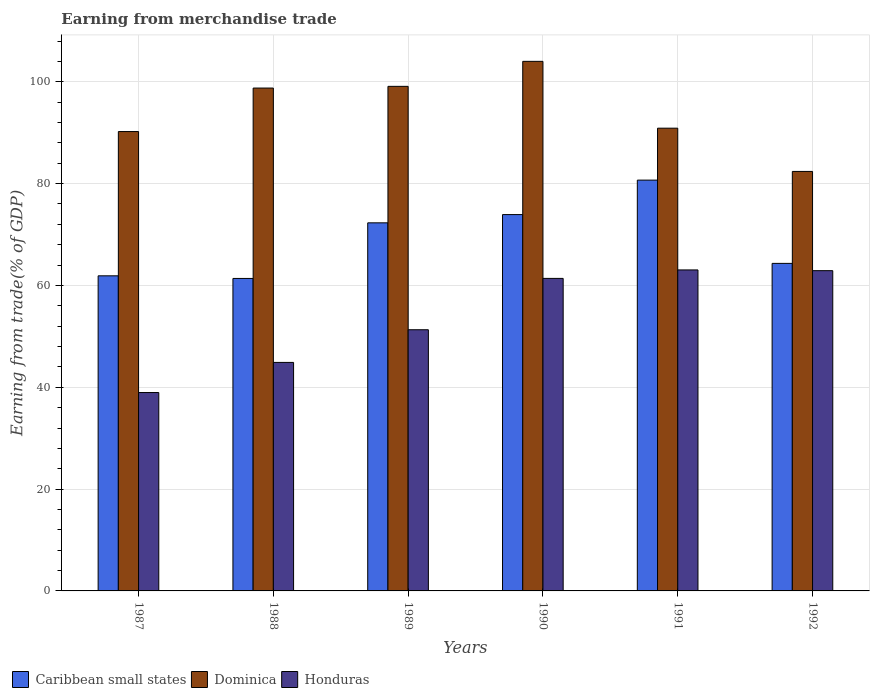How many groups of bars are there?
Offer a terse response. 6. Are the number of bars per tick equal to the number of legend labels?
Ensure brevity in your answer.  Yes. Are the number of bars on each tick of the X-axis equal?
Provide a succinct answer. Yes. How many bars are there on the 5th tick from the right?
Give a very brief answer. 3. What is the label of the 6th group of bars from the left?
Provide a succinct answer. 1992. In how many cases, is the number of bars for a given year not equal to the number of legend labels?
Ensure brevity in your answer.  0. What is the earnings from trade in Caribbean small states in 1990?
Keep it short and to the point. 73.92. Across all years, what is the maximum earnings from trade in Dominica?
Give a very brief answer. 104.01. Across all years, what is the minimum earnings from trade in Dominica?
Keep it short and to the point. 82.39. In which year was the earnings from trade in Honduras maximum?
Give a very brief answer. 1991. What is the total earnings from trade in Honduras in the graph?
Offer a terse response. 322.48. What is the difference between the earnings from trade in Caribbean small states in 1988 and that in 1991?
Provide a succinct answer. -19.31. What is the difference between the earnings from trade in Honduras in 1988 and the earnings from trade in Dominica in 1991?
Your answer should be very brief. -46.01. What is the average earnings from trade in Dominica per year?
Your response must be concise. 94.23. In the year 1988, what is the difference between the earnings from trade in Honduras and earnings from trade in Caribbean small states?
Keep it short and to the point. -16.49. What is the ratio of the earnings from trade in Caribbean small states in 1989 to that in 1990?
Your answer should be compact. 0.98. What is the difference between the highest and the second highest earnings from trade in Caribbean small states?
Your answer should be very brief. 6.77. What is the difference between the highest and the lowest earnings from trade in Caribbean small states?
Provide a short and direct response. 19.31. In how many years, is the earnings from trade in Caribbean small states greater than the average earnings from trade in Caribbean small states taken over all years?
Ensure brevity in your answer.  3. Is the sum of the earnings from trade in Dominica in 1989 and 1991 greater than the maximum earnings from trade in Honduras across all years?
Provide a succinct answer. Yes. What does the 2nd bar from the left in 1988 represents?
Your answer should be very brief. Dominica. What does the 2nd bar from the right in 1988 represents?
Your answer should be very brief. Dominica. Is it the case that in every year, the sum of the earnings from trade in Caribbean small states and earnings from trade in Dominica is greater than the earnings from trade in Honduras?
Ensure brevity in your answer.  Yes. How many bars are there?
Your response must be concise. 18. How many years are there in the graph?
Offer a very short reply. 6. Are the values on the major ticks of Y-axis written in scientific E-notation?
Make the answer very short. No. Does the graph contain grids?
Your answer should be compact. Yes. Where does the legend appear in the graph?
Ensure brevity in your answer.  Bottom left. How many legend labels are there?
Give a very brief answer. 3. How are the legend labels stacked?
Your answer should be very brief. Horizontal. What is the title of the graph?
Your answer should be very brief. Earning from merchandise trade. What is the label or title of the Y-axis?
Offer a very short reply. Earning from trade(% of GDP). What is the Earning from trade(% of GDP) in Caribbean small states in 1987?
Provide a short and direct response. 61.89. What is the Earning from trade(% of GDP) in Dominica in 1987?
Provide a short and direct response. 90.23. What is the Earning from trade(% of GDP) of Honduras in 1987?
Ensure brevity in your answer.  38.96. What is the Earning from trade(% of GDP) of Caribbean small states in 1988?
Give a very brief answer. 61.38. What is the Earning from trade(% of GDP) in Dominica in 1988?
Your answer should be compact. 98.77. What is the Earning from trade(% of GDP) of Honduras in 1988?
Keep it short and to the point. 44.88. What is the Earning from trade(% of GDP) of Caribbean small states in 1989?
Provide a short and direct response. 72.3. What is the Earning from trade(% of GDP) of Dominica in 1989?
Offer a terse response. 99.1. What is the Earning from trade(% of GDP) of Honduras in 1989?
Give a very brief answer. 51.3. What is the Earning from trade(% of GDP) in Caribbean small states in 1990?
Provide a succinct answer. 73.92. What is the Earning from trade(% of GDP) of Dominica in 1990?
Your answer should be compact. 104.01. What is the Earning from trade(% of GDP) of Honduras in 1990?
Offer a very short reply. 61.38. What is the Earning from trade(% of GDP) in Caribbean small states in 1991?
Keep it short and to the point. 80.69. What is the Earning from trade(% of GDP) in Dominica in 1991?
Provide a succinct answer. 90.89. What is the Earning from trade(% of GDP) of Honduras in 1991?
Offer a terse response. 63.05. What is the Earning from trade(% of GDP) of Caribbean small states in 1992?
Provide a short and direct response. 64.33. What is the Earning from trade(% of GDP) of Dominica in 1992?
Offer a very short reply. 82.39. What is the Earning from trade(% of GDP) of Honduras in 1992?
Your answer should be compact. 62.9. Across all years, what is the maximum Earning from trade(% of GDP) in Caribbean small states?
Offer a very short reply. 80.69. Across all years, what is the maximum Earning from trade(% of GDP) in Dominica?
Make the answer very short. 104.01. Across all years, what is the maximum Earning from trade(% of GDP) of Honduras?
Offer a very short reply. 63.05. Across all years, what is the minimum Earning from trade(% of GDP) of Caribbean small states?
Give a very brief answer. 61.38. Across all years, what is the minimum Earning from trade(% of GDP) in Dominica?
Ensure brevity in your answer.  82.39. Across all years, what is the minimum Earning from trade(% of GDP) in Honduras?
Provide a short and direct response. 38.96. What is the total Earning from trade(% of GDP) of Caribbean small states in the graph?
Keep it short and to the point. 414.5. What is the total Earning from trade(% of GDP) in Dominica in the graph?
Offer a terse response. 565.4. What is the total Earning from trade(% of GDP) of Honduras in the graph?
Make the answer very short. 322.48. What is the difference between the Earning from trade(% of GDP) in Caribbean small states in 1987 and that in 1988?
Ensure brevity in your answer.  0.51. What is the difference between the Earning from trade(% of GDP) in Dominica in 1987 and that in 1988?
Offer a terse response. -8.54. What is the difference between the Earning from trade(% of GDP) in Honduras in 1987 and that in 1988?
Offer a terse response. -5.92. What is the difference between the Earning from trade(% of GDP) of Caribbean small states in 1987 and that in 1989?
Keep it short and to the point. -10.41. What is the difference between the Earning from trade(% of GDP) of Dominica in 1987 and that in 1989?
Provide a succinct answer. -8.88. What is the difference between the Earning from trade(% of GDP) of Honduras in 1987 and that in 1989?
Make the answer very short. -12.33. What is the difference between the Earning from trade(% of GDP) of Caribbean small states in 1987 and that in 1990?
Offer a very short reply. -12.03. What is the difference between the Earning from trade(% of GDP) in Dominica in 1987 and that in 1990?
Make the answer very short. -13.79. What is the difference between the Earning from trade(% of GDP) in Honduras in 1987 and that in 1990?
Your response must be concise. -22.42. What is the difference between the Earning from trade(% of GDP) in Caribbean small states in 1987 and that in 1991?
Offer a terse response. -18.8. What is the difference between the Earning from trade(% of GDP) in Dominica in 1987 and that in 1991?
Keep it short and to the point. -0.66. What is the difference between the Earning from trade(% of GDP) of Honduras in 1987 and that in 1991?
Give a very brief answer. -24.08. What is the difference between the Earning from trade(% of GDP) in Caribbean small states in 1987 and that in 1992?
Offer a terse response. -2.44. What is the difference between the Earning from trade(% of GDP) in Dominica in 1987 and that in 1992?
Keep it short and to the point. 7.83. What is the difference between the Earning from trade(% of GDP) of Honduras in 1987 and that in 1992?
Your answer should be compact. -23.94. What is the difference between the Earning from trade(% of GDP) in Caribbean small states in 1988 and that in 1989?
Offer a very short reply. -10.92. What is the difference between the Earning from trade(% of GDP) in Dominica in 1988 and that in 1989?
Your answer should be compact. -0.33. What is the difference between the Earning from trade(% of GDP) in Honduras in 1988 and that in 1989?
Your answer should be very brief. -6.42. What is the difference between the Earning from trade(% of GDP) of Caribbean small states in 1988 and that in 1990?
Your response must be concise. -12.54. What is the difference between the Earning from trade(% of GDP) in Dominica in 1988 and that in 1990?
Your response must be concise. -5.24. What is the difference between the Earning from trade(% of GDP) in Honduras in 1988 and that in 1990?
Ensure brevity in your answer.  -16.5. What is the difference between the Earning from trade(% of GDP) of Caribbean small states in 1988 and that in 1991?
Offer a terse response. -19.31. What is the difference between the Earning from trade(% of GDP) in Dominica in 1988 and that in 1991?
Provide a succinct answer. 7.88. What is the difference between the Earning from trade(% of GDP) of Honduras in 1988 and that in 1991?
Ensure brevity in your answer.  -18.17. What is the difference between the Earning from trade(% of GDP) of Caribbean small states in 1988 and that in 1992?
Offer a terse response. -2.96. What is the difference between the Earning from trade(% of GDP) of Dominica in 1988 and that in 1992?
Offer a very short reply. 16.38. What is the difference between the Earning from trade(% of GDP) of Honduras in 1988 and that in 1992?
Provide a short and direct response. -18.02. What is the difference between the Earning from trade(% of GDP) in Caribbean small states in 1989 and that in 1990?
Provide a short and direct response. -1.62. What is the difference between the Earning from trade(% of GDP) in Dominica in 1989 and that in 1990?
Your response must be concise. -4.91. What is the difference between the Earning from trade(% of GDP) of Honduras in 1989 and that in 1990?
Your response must be concise. -10.08. What is the difference between the Earning from trade(% of GDP) of Caribbean small states in 1989 and that in 1991?
Keep it short and to the point. -8.39. What is the difference between the Earning from trade(% of GDP) in Dominica in 1989 and that in 1991?
Provide a succinct answer. 8.21. What is the difference between the Earning from trade(% of GDP) in Honduras in 1989 and that in 1991?
Offer a very short reply. -11.75. What is the difference between the Earning from trade(% of GDP) in Caribbean small states in 1989 and that in 1992?
Your answer should be very brief. 7.97. What is the difference between the Earning from trade(% of GDP) in Dominica in 1989 and that in 1992?
Provide a short and direct response. 16.71. What is the difference between the Earning from trade(% of GDP) of Honduras in 1989 and that in 1992?
Make the answer very short. -11.6. What is the difference between the Earning from trade(% of GDP) of Caribbean small states in 1990 and that in 1991?
Your answer should be compact. -6.77. What is the difference between the Earning from trade(% of GDP) in Dominica in 1990 and that in 1991?
Provide a succinct answer. 13.12. What is the difference between the Earning from trade(% of GDP) of Honduras in 1990 and that in 1991?
Provide a succinct answer. -1.67. What is the difference between the Earning from trade(% of GDP) in Caribbean small states in 1990 and that in 1992?
Ensure brevity in your answer.  9.59. What is the difference between the Earning from trade(% of GDP) of Dominica in 1990 and that in 1992?
Make the answer very short. 21.62. What is the difference between the Earning from trade(% of GDP) of Honduras in 1990 and that in 1992?
Ensure brevity in your answer.  -1.52. What is the difference between the Earning from trade(% of GDP) in Caribbean small states in 1991 and that in 1992?
Keep it short and to the point. 16.35. What is the difference between the Earning from trade(% of GDP) of Dominica in 1991 and that in 1992?
Offer a very short reply. 8.5. What is the difference between the Earning from trade(% of GDP) in Honduras in 1991 and that in 1992?
Give a very brief answer. 0.15. What is the difference between the Earning from trade(% of GDP) in Caribbean small states in 1987 and the Earning from trade(% of GDP) in Dominica in 1988?
Offer a very short reply. -36.88. What is the difference between the Earning from trade(% of GDP) of Caribbean small states in 1987 and the Earning from trade(% of GDP) of Honduras in 1988?
Keep it short and to the point. 17.01. What is the difference between the Earning from trade(% of GDP) in Dominica in 1987 and the Earning from trade(% of GDP) in Honduras in 1988?
Give a very brief answer. 45.34. What is the difference between the Earning from trade(% of GDP) of Caribbean small states in 1987 and the Earning from trade(% of GDP) of Dominica in 1989?
Offer a very short reply. -37.21. What is the difference between the Earning from trade(% of GDP) of Caribbean small states in 1987 and the Earning from trade(% of GDP) of Honduras in 1989?
Keep it short and to the point. 10.59. What is the difference between the Earning from trade(% of GDP) of Dominica in 1987 and the Earning from trade(% of GDP) of Honduras in 1989?
Offer a very short reply. 38.93. What is the difference between the Earning from trade(% of GDP) in Caribbean small states in 1987 and the Earning from trade(% of GDP) in Dominica in 1990?
Give a very brief answer. -42.12. What is the difference between the Earning from trade(% of GDP) in Caribbean small states in 1987 and the Earning from trade(% of GDP) in Honduras in 1990?
Keep it short and to the point. 0.51. What is the difference between the Earning from trade(% of GDP) in Dominica in 1987 and the Earning from trade(% of GDP) in Honduras in 1990?
Provide a short and direct response. 28.84. What is the difference between the Earning from trade(% of GDP) of Caribbean small states in 1987 and the Earning from trade(% of GDP) of Dominica in 1991?
Give a very brief answer. -29. What is the difference between the Earning from trade(% of GDP) in Caribbean small states in 1987 and the Earning from trade(% of GDP) in Honduras in 1991?
Keep it short and to the point. -1.16. What is the difference between the Earning from trade(% of GDP) in Dominica in 1987 and the Earning from trade(% of GDP) in Honduras in 1991?
Your answer should be compact. 27.18. What is the difference between the Earning from trade(% of GDP) in Caribbean small states in 1987 and the Earning from trade(% of GDP) in Dominica in 1992?
Offer a very short reply. -20.5. What is the difference between the Earning from trade(% of GDP) in Caribbean small states in 1987 and the Earning from trade(% of GDP) in Honduras in 1992?
Offer a terse response. -1.01. What is the difference between the Earning from trade(% of GDP) of Dominica in 1987 and the Earning from trade(% of GDP) of Honduras in 1992?
Provide a short and direct response. 27.32. What is the difference between the Earning from trade(% of GDP) of Caribbean small states in 1988 and the Earning from trade(% of GDP) of Dominica in 1989?
Ensure brevity in your answer.  -37.73. What is the difference between the Earning from trade(% of GDP) in Caribbean small states in 1988 and the Earning from trade(% of GDP) in Honduras in 1989?
Ensure brevity in your answer.  10.08. What is the difference between the Earning from trade(% of GDP) of Dominica in 1988 and the Earning from trade(% of GDP) of Honduras in 1989?
Keep it short and to the point. 47.47. What is the difference between the Earning from trade(% of GDP) of Caribbean small states in 1988 and the Earning from trade(% of GDP) of Dominica in 1990?
Ensure brevity in your answer.  -42.64. What is the difference between the Earning from trade(% of GDP) in Caribbean small states in 1988 and the Earning from trade(% of GDP) in Honduras in 1990?
Your answer should be compact. -0.01. What is the difference between the Earning from trade(% of GDP) in Dominica in 1988 and the Earning from trade(% of GDP) in Honduras in 1990?
Keep it short and to the point. 37.39. What is the difference between the Earning from trade(% of GDP) in Caribbean small states in 1988 and the Earning from trade(% of GDP) in Dominica in 1991?
Your answer should be compact. -29.51. What is the difference between the Earning from trade(% of GDP) of Caribbean small states in 1988 and the Earning from trade(% of GDP) of Honduras in 1991?
Ensure brevity in your answer.  -1.67. What is the difference between the Earning from trade(% of GDP) in Dominica in 1988 and the Earning from trade(% of GDP) in Honduras in 1991?
Your response must be concise. 35.72. What is the difference between the Earning from trade(% of GDP) of Caribbean small states in 1988 and the Earning from trade(% of GDP) of Dominica in 1992?
Give a very brief answer. -21.02. What is the difference between the Earning from trade(% of GDP) of Caribbean small states in 1988 and the Earning from trade(% of GDP) of Honduras in 1992?
Your answer should be compact. -1.53. What is the difference between the Earning from trade(% of GDP) of Dominica in 1988 and the Earning from trade(% of GDP) of Honduras in 1992?
Provide a short and direct response. 35.87. What is the difference between the Earning from trade(% of GDP) of Caribbean small states in 1989 and the Earning from trade(% of GDP) of Dominica in 1990?
Keep it short and to the point. -31.72. What is the difference between the Earning from trade(% of GDP) in Caribbean small states in 1989 and the Earning from trade(% of GDP) in Honduras in 1990?
Make the answer very short. 10.92. What is the difference between the Earning from trade(% of GDP) of Dominica in 1989 and the Earning from trade(% of GDP) of Honduras in 1990?
Your answer should be very brief. 37.72. What is the difference between the Earning from trade(% of GDP) in Caribbean small states in 1989 and the Earning from trade(% of GDP) in Dominica in 1991?
Give a very brief answer. -18.59. What is the difference between the Earning from trade(% of GDP) of Caribbean small states in 1989 and the Earning from trade(% of GDP) of Honduras in 1991?
Your response must be concise. 9.25. What is the difference between the Earning from trade(% of GDP) in Dominica in 1989 and the Earning from trade(% of GDP) in Honduras in 1991?
Give a very brief answer. 36.06. What is the difference between the Earning from trade(% of GDP) in Caribbean small states in 1989 and the Earning from trade(% of GDP) in Dominica in 1992?
Your answer should be compact. -10.1. What is the difference between the Earning from trade(% of GDP) in Caribbean small states in 1989 and the Earning from trade(% of GDP) in Honduras in 1992?
Your answer should be compact. 9.4. What is the difference between the Earning from trade(% of GDP) of Dominica in 1989 and the Earning from trade(% of GDP) of Honduras in 1992?
Give a very brief answer. 36.2. What is the difference between the Earning from trade(% of GDP) in Caribbean small states in 1990 and the Earning from trade(% of GDP) in Dominica in 1991?
Your response must be concise. -16.97. What is the difference between the Earning from trade(% of GDP) of Caribbean small states in 1990 and the Earning from trade(% of GDP) of Honduras in 1991?
Provide a succinct answer. 10.87. What is the difference between the Earning from trade(% of GDP) in Dominica in 1990 and the Earning from trade(% of GDP) in Honduras in 1991?
Your answer should be very brief. 40.97. What is the difference between the Earning from trade(% of GDP) in Caribbean small states in 1990 and the Earning from trade(% of GDP) in Dominica in 1992?
Your answer should be very brief. -8.48. What is the difference between the Earning from trade(% of GDP) of Caribbean small states in 1990 and the Earning from trade(% of GDP) of Honduras in 1992?
Offer a very short reply. 11.02. What is the difference between the Earning from trade(% of GDP) of Dominica in 1990 and the Earning from trade(% of GDP) of Honduras in 1992?
Ensure brevity in your answer.  41.11. What is the difference between the Earning from trade(% of GDP) in Caribbean small states in 1991 and the Earning from trade(% of GDP) in Dominica in 1992?
Your response must be concise. -1.71. What is the difference between the Earning from trade(% of GDP) of Caribbean small states in 1991 and the Earning from trade(% of GDP) of Honduras in 1992?
Your answer should be very brief. 17.79. What is the difference between the Earning from trade(% of GDP) of Dominica in 1991 and the Earning from trade(% of GDP) of Honduras in 1992?
Your answer should be compact. 27.99. What is the average Earning from trade(% of GDP) of Caribbean small states per year?
Your answer should be compact. 69.08. What is the average Earning from trade(% of GDP) of Dominica per year?
Your response must be concise. 94.23. What is the average Earning from trade(% of GDP) of Honduras per year?
Provide a short and direct response. 53.75. In the year 1987, what is the difference between the Earning from trade(% of GDP) in Caribbean small states and Earning from trade(% of GDP) in Dominica?
Ensure brevity in your answer.  -28.34. In the year 1987, what is the difference between the Earning from trade(% of GDP) in Caribbean small states and Earning from trade(% of GDP) in Honduras?
Give a very brief answer. 22.93. In the year 1987, what is the difference between the Earning from trade(% of GDP) of Dominica and Earning from trade(% of GDP) of Honduras?
Make the answer very short. 51.26. In the year 1988, what is the difference between the Earning from trade(% of GDP) of Caribbean small states and Earning from trade(% of GDP) of Dominica?
Offer a terse response. -37.4. In the year 1988, what is the difference between the Earning from trade(% of GDP) of Caribbean small states and Earning from trade(% of GDP) of Honduras?
Offer a terse response. 16.49. In the year 1988, what is the difference between the Earning from trade(% of GDP) of Dominica and Earning from trade(% of GDP) of Honduras?
Your answer should be very brief. 53.89. In the year 1989, what is the difference between the Earning from trade(% of GDP) of Caribbean small states and Earning from trade(% of GDP) of Dominica?
Your response must be concise. -26.81. In the year 1989, what is the difference between the Earning from trade(% of GDP) of Caribbean small states and Earning from trade(% of GDP) of Honduras?
Keep it short and to the point. 21. In the year 1989, what is the difference between the Earning from trade(% of GDP) in Dominica and Earning from trade(% of GDP) in Honduras?
Offer a terse response. 47.81. In the year 1990, what is the difference between the Earning from trade(% of GDP) in Caribbean small states and Earning from trade(% of GDP) in Dominica?
Your answer should be compact. -30.1. In the year 1990, what is the difference between the Earning from trade(% of GDP) of Caribbean small states and Earning from trade(% of GDP) of Honduras?
Offer a very short reply. 12.54. In the year 1990, what is the difference between the Earning from trade(% of GDP) of Dominica and Earning from trade(% of GDP) of Honduras?
Provide a short and direct response. 42.63. In the year 1991, what is the difference between the Earning from trade(% of GDP) in Caribbean small states and Earning from trade(% of GDP) in Dominica?
Provide a short and direct response. -10.2. In the year 1991, what is the difference between the Earning from trade(% of GDP) in Caribbean small states and Earning from trade(% of GDP) in Honduras?
Provide a succinct answer. 17.64. In the year 1991, what is the difference between the Earning from trade(% of GDP) in Dominica and Earning from trade(% of GDP) in Honduras?
Give a very brief answer. 27.84. In the year 1992, what is the difference between the Earning from trade(% of GDP) of Caribbean small states and Earning from trade(% of GDP) of Dominica?
Keep it short and to the point. -18.06. In the year 1992, what is the difference between the Earning from trade(% of GDP) in Caribbean small states and Earning from trade(% of GDP) in Honduras?
Your response must be concise. 1.43. In the year 1992, what is the difference between the Earning from trade(% of GDP) of Dominica and Earning from trade(% of GDP) of Honduras?
Your response must be concise. 19.49. What is the ratio of the Earning from trade(% of GDP) of Caribbean small states in 1987 to that in 1988?
Make the answer very short. 1.01. What is the ratio of the Earning from trade(% of GDP) in Dominica in 1987 to that in 1988?
Provide a succinct answer. 0.91. What is the ratio of the Earning from trade(% of GDP) in Honduras in 1987 to that in 1988?
Ensure brevity in your answer.  0.87. What is the ratio of the Earning from trade(% of GDP) of Caribbean small states in 1987 to that in 1989?
Ensure brevity in your answer.  0.86. What is the ratio of the Earning from trade(% of GDP) of Dominica in 1987 to that in 1989?
Your response must be concise. 0.91. What is the ratio of the Earning from trade(% of GDP) of Honduras in 1987 to that in 1989?
Your answer should be very brief. 0.76. What is the ratio of the Earning from trade(% of GDP) in Caribbean small states in 1987 to that in 1990?
Ensure brevity in your answer.  0.84. What is the ratio of the Earning from trade(% of GDP) of Dominica in 1987 to that in 1990?
Your answer should be very brief. 0.87. What is the ratio of the Earning from trade(% of GDP) in Honduras in 1987 to that in 1990?
Provide a short and direct response. 0.63. What is the ratio of the Earning from trade(% of GDP) of Caribbean small states in 1987 to that in 1991?
Provide a short and direct response. 0.77. What is the ratio of the Earning from trade(% of GDP) of Dominica in 1987 to that in 1991?
Provide a short and direct response. 0.99. What is the ratio of the Earning from trade(% of GDP) of Honduras in 1987 to that in 1991?
Provide a succinct answer. 0.62. What is the ratio of the Earning from trade(% of GDP) of Caribbean small states in 1987 to that in 1992?
Your answer should be compact. 0.96. What is the ratio of the Earning from trade(% of GDP) of Dominica in 1987 to that in 1992?
Provide a succinct answer. 1.1. What is the ratio of the Earning from trade(% of GDP) of Honduras in 1987 to that in 1992?
Provide a short and direct response. 0.62. What is the ratio of the Earning from trade(% of GDP) of Caribbean small states in 1988 to that in 1989?
Your response must be concise. 0.85. What is the ratio of the Earning from trade(% of GDP) of Honduras in 1988 to that in 1989?
Your answer should be compact. 0.87. What is the ratio of the Earning from trade(% of GDP) of Caribbean small states in 1988 to that in 1990?
Offer a terse response. 0.83. What is the ratio of the Earning from trade(% of GDP) in Dominica in 1988 to that in 1990?
Provide a succinct answer. 0.95. What is the ratio of the Earning from trade(% of GDP) in Honduras in 1988 to that in 1990?
Offer a terse response. 0.73. What is the ratio of the Earning from trade(% of GDP) in Caribbean small states in 1988 to that in 1991?
Your response must be concise. 0.76. What is the ratio of the Earning from trade(% of GDP) of Dominica in 1988 to that in 1991?
Make the answer very short. 1.09. What is the ratio of the Earning from trade(% of GDP) in Honduras in 1988 to that in 1991?
Keep it short and to the point. 0.71. What is the ratio of the Earning from trade(% of GDP) of Caribbean small states in 1988 to that in 1992?
Your answer should be very brief. 0.95. What is the ratio of the Earning from trade(% of GDP) of Dominica in 1988 to that in 1992?
Your answer should be compact. 1.2. What is the ratio of the Earning from trade(% of GDP) of Honduras in 1988 to that in 1992?
Provide a succinct answer. 0.71. What is the ratio of the Earning from trade(% of GDP) in Caribbean small states in 1989 to that in 1990?
Offer a very short reply. 0.98. What is the ratio of the Earning from trade(% of GDP) in Dominica in 1989 to that in 1990?
Offer a very short reply. 0.95. What is the ratio of the Earning from trade(% of GDP) of Honduras in 1989 to that in 1990?
Provide a succinct answer. 0.84. What is the ratio of the Earning from trade(% of GDP) of Caribbean small states in 1989 to that in 1991?
Your answer should be compact. 0.9. What is the ratio of the Earning from trade(% of GDP) in Dominica in 1989 to that in 1991?
Give a very brief answer. 1.09. What is the ratio of the Earning from trade(% of GDP) of Honduras in 1989 to that in 1991?
Your answer should be compact. 0.81. What is the ratio of the Earning from trade(% of GDP) in Caribbean small states in 1989 to that in 1992?
Make the answer very short. 1.12. What is the ratio of the Earning from trade(% of GDP) in Dominica in 1989 to that in 1992?
Provide a succinct answer. 1.2. What is the ratio of the Earning from trade(% of GDP) of Honduras in 1989 to that in 1992?
Provide a short and direct response. 0.82. What is the ratio of the Earning from trade(% of GDP) in Caribbean small states in 1990 to that in 1991?
Provide a succinct answer. 0.92. What is the ratio of the Earning from trade(% of GDP) in Dominica in 1990 to that in 1991?
Give a very brief answer. 1.14. What is the ratio of the Earning from trade(% of GDP) in Honduras in 1990 to that in 1991?
Provide a short and direct response. 0.97. What is the ratio of the Earning from trade(% of GDP) in Caribbean small states in 1990 to that in 1992?
Ensure brevity in your answer.  1.15. What is the ratio of the Earning from trade(% of GDP) of Dominica in 1990 to that in 1992?
Ensure brevity in your answer.  1.26. What is the ratio of the Earning from trade(% of GDP) in Honduras in 1990 to that in 1992?
Offer a very short reply. 0.98. What is the ratio of the Earning from trade(% of GDP) in Caribbean small states in 1991 to that in 1992?
Offer a very short reply. 1.25. What is the ratio of the Earning from trade(% of GDP) of Dominica in 1991 to that in 1992?
Ensure brevity in your answer.  1.1. What is the ratio of the Earning from trade(% of GDP) of Honduras in 1991 to that in 1992?
Give a very brief answer. 1. What is the difference between the highest and the second highest Earning from trade(% of GDP) in Caribbean small states?
Your answer should be very brief. 6.77. What is the difference between the highest and the second highest Earning from trade(% of GDP) of Dominica?
Your answer should be very brief. 4.91. What is the difference between the highest and the second highest Earning from trade(% of GDP) of Honduras?
Offer a terse response. 0.15. What is the difference between the highest and the lowest Earning from trade(% of GDP) of Caribbean small states?
Offer a very short reply. 19.31. What is the difference between the highest and the lowest Earning from trade(% of GDP) in Dominica?
Ensure brevity in your answer.  21.62. What is the difference between the highest and the lowest Earning from trade(% of GDP) in Honduras?
Offer a very short reply. 24.08. 